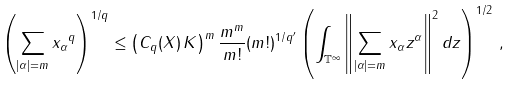Convert formula to latex. <formula><loc_0><loc_0><loc_500><loc_500>\left ( \sum _ { | \alpha | = m } \| x _ { \alpha } \| ^ { q } \right ) ^ { 1 / q } \leq \left ( C _ { q } ( X ) \, K \right ) ^ { m } \frac { m ^ { m } } { m ! } ( m ! ) ^ { 1 / q ^ { \prime } } \left ( \int _ { \mathbb { T } ^ { \infty } } \left \| \sum _ { | \alpha | = m } x _ { \alpha } z ^ { \alpha } \right \| ^ { 2 } d z \right ) ^ { 1 / 2 } \, ,</formula> 